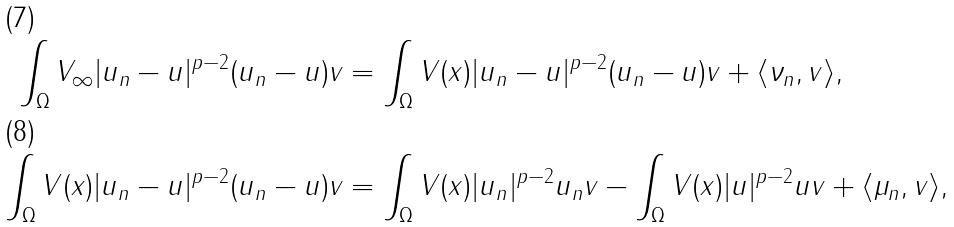<formula> <loc_0><loc_0><loc_500><loc_500>\int _ { \Omega } V _ { \infty } | u _ { n } - u | ^ { p - 2 } ( u _ { n } - u ) v & = \int _ { \Omega } V ( x ) | u _ { n } - u | ^ { p - 2 } ( u _ { n } - u ) v + \langle \nu _ { n } , v \rangle , \\ \int _ { \Omega } V ( x ) | u _ { n } - u | ^ { p - 2 } ( u _ { n } - u ) v & = \int _ { \Omega } V ( x ) | u _ { n } | ^ { p - 2 } u _ { n } v - \int _ { \Omega } V ( x ) | u | ^ { p - 2 } u v + \langle \mu _ { n } , v \rangle ,</formula> 